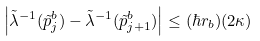Convert formula to latex. <formula><loc_0><loc_0><loc_500><loc_500>\left | \tilde { \lambda } ^ { - 1 } ( \tilde { p } ^ { b } _ { j } ) - \tilde { \lambda } ^ { - 1 } ( \tilde { p } ^ { b } _ { j + 1 } ) \right | \leq ( \hbar { r } _ { b } ) ( 2 \kappa )</formula> 